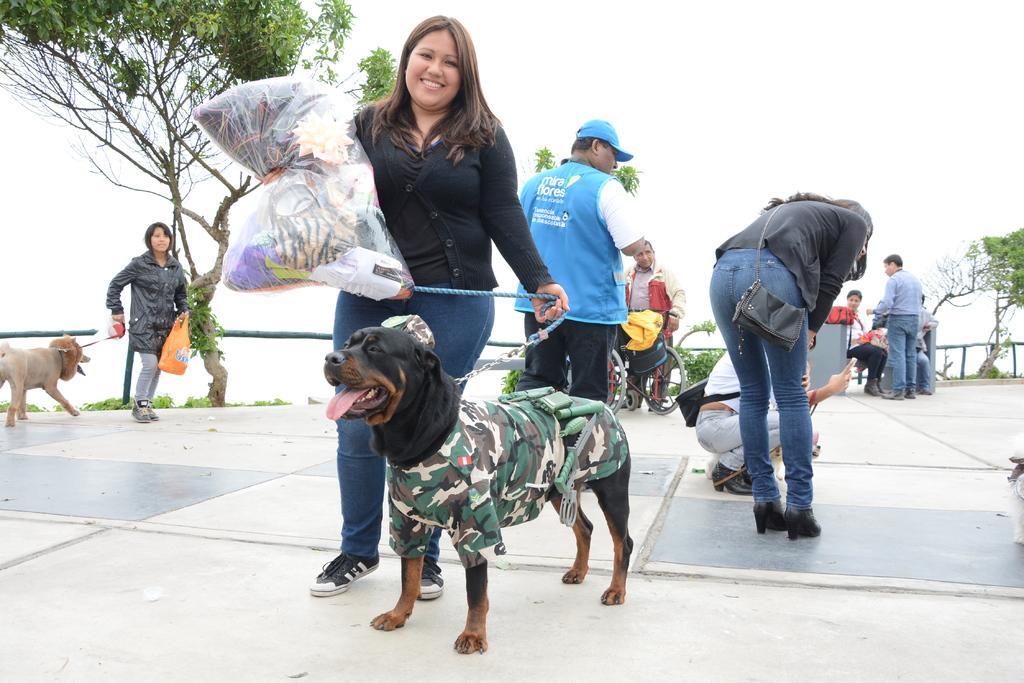Please provide a concise description of this image. In this image we can see there are some persons standing and holding some objects and a dog belts. There is a tree on the left side of this image and on the right side of this image as well. There is a ground at the bottom of this image and there is a sky at the top of this image. 